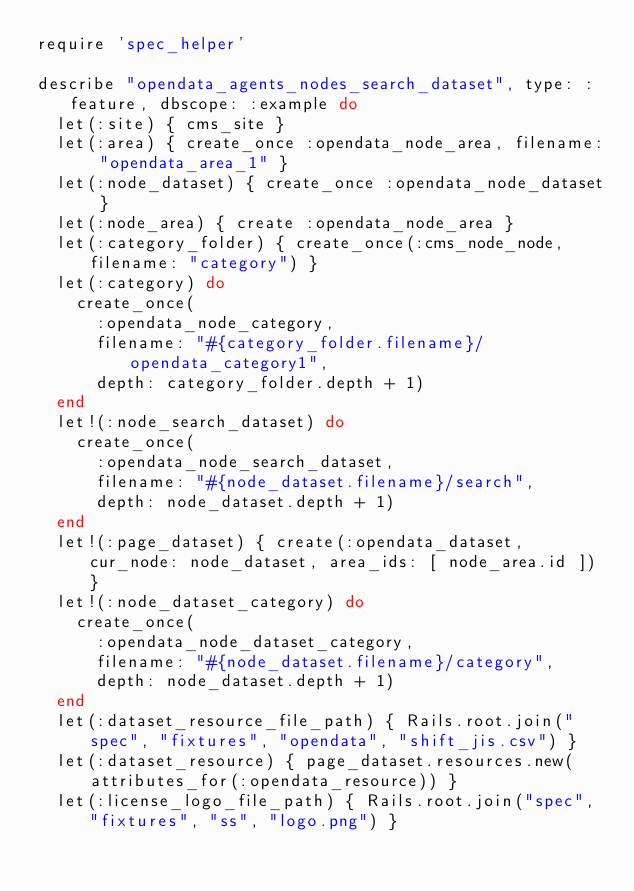<code> <loc_0><loc_0><loc_500><loc_500><_Ruby_>require 'spec_helper'

describe "opendata_agents_nodes_search_dataset", type: :feature, dbscope: :example do
  let(:site) { cms_site }
  let(:area) { create_once :opendata_node_area, filename: "opendata_area_1" }
  let(:node_dataset) { create_once :opendata_node_dataset }
  let(:node_area) { create :opendata_node_area }
  let(:category_folder) { create_once(:cms_node_node, filename: "category") }
  let(:category) do
    create_once(
      :opendata_node_category,
      filename: "#{category_folder.filename}/opendata_category1",
      depth: category_folder.depth + 1)
  end
  let!(:node_search_dataset) do
    create_once(
      :opendata_node_search_dataset,
      filename: "#{node_dataset.filename}/search",
      depth: node_dataset.depth + 1)
  end
  let!(:page_dataset) { create(:opendata_dataset, cur_node: node_dataset, area_ids: [ node_area.id ]) }
  let!(:node_dataset_category) do
    create_once(
      :opendata_node_dataset_category,
      filename: "#{node_dataset.filename}/category",
      depth: node_dataset.depth + 1)
  end
  let(:dataset_resource_file_path) { Rails.root.join("spec", "fixtures", "opendata", "shift_jis.csv") }
  let(:dataset_resource) { page_dataset.resources.new(attributes_for(:opendata_resource)) }
  let(:license_logo_file_path) { Rails.root.join("spec", "fixtures", "ss", "logo.png") }</code> 